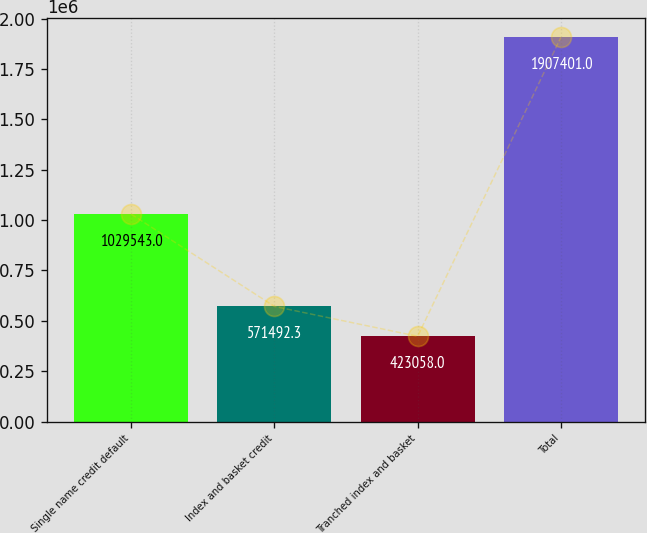<chart> <loc_0><loc_0><loc_500><loc_500><bar_chart><fcel>Single name credit default<fcel>Index and basket credit<fcel>Tranched index and basket<fcel>Total<nl><fcel>1.02954e+06<fcel>571492<fcel>423058<fcel>1.9074e+06<nl></chart> 